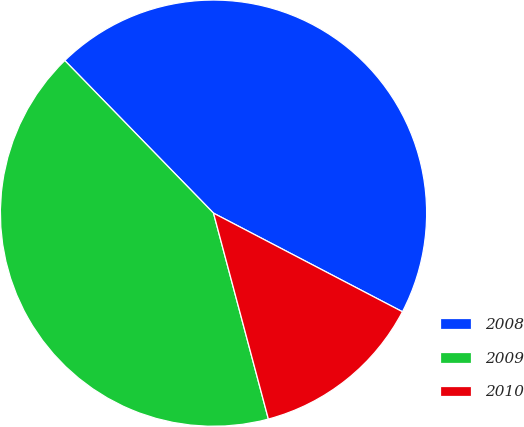Convert chart to OTSL. <chart><loc_0><loc_0><loc_500><loc_500><pie_chart><fcel>2008<fcel>2009<fcel>2010<nl><fcel>44.95%<fcel>41.85%<fcel>13.2%<nl></chart> 